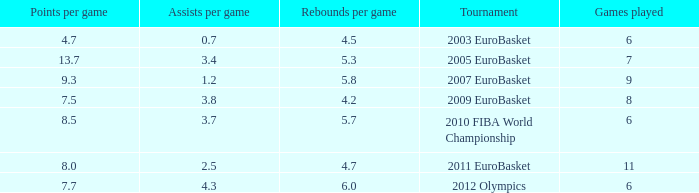How many points per game have the tournament 2005 eurobasket? 13.7. 